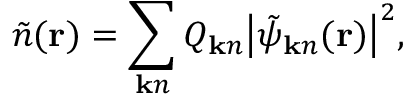<formula> <loc_0><loc_0><loc_500><loc_500>\tilde { n } ( { r } ) = \sum _ { { k } n } Q _ { { k } n } \left | \tilde { \psi } _ { { k } n } ( { r } ) \right | ^ { 2 } ,</formula> 